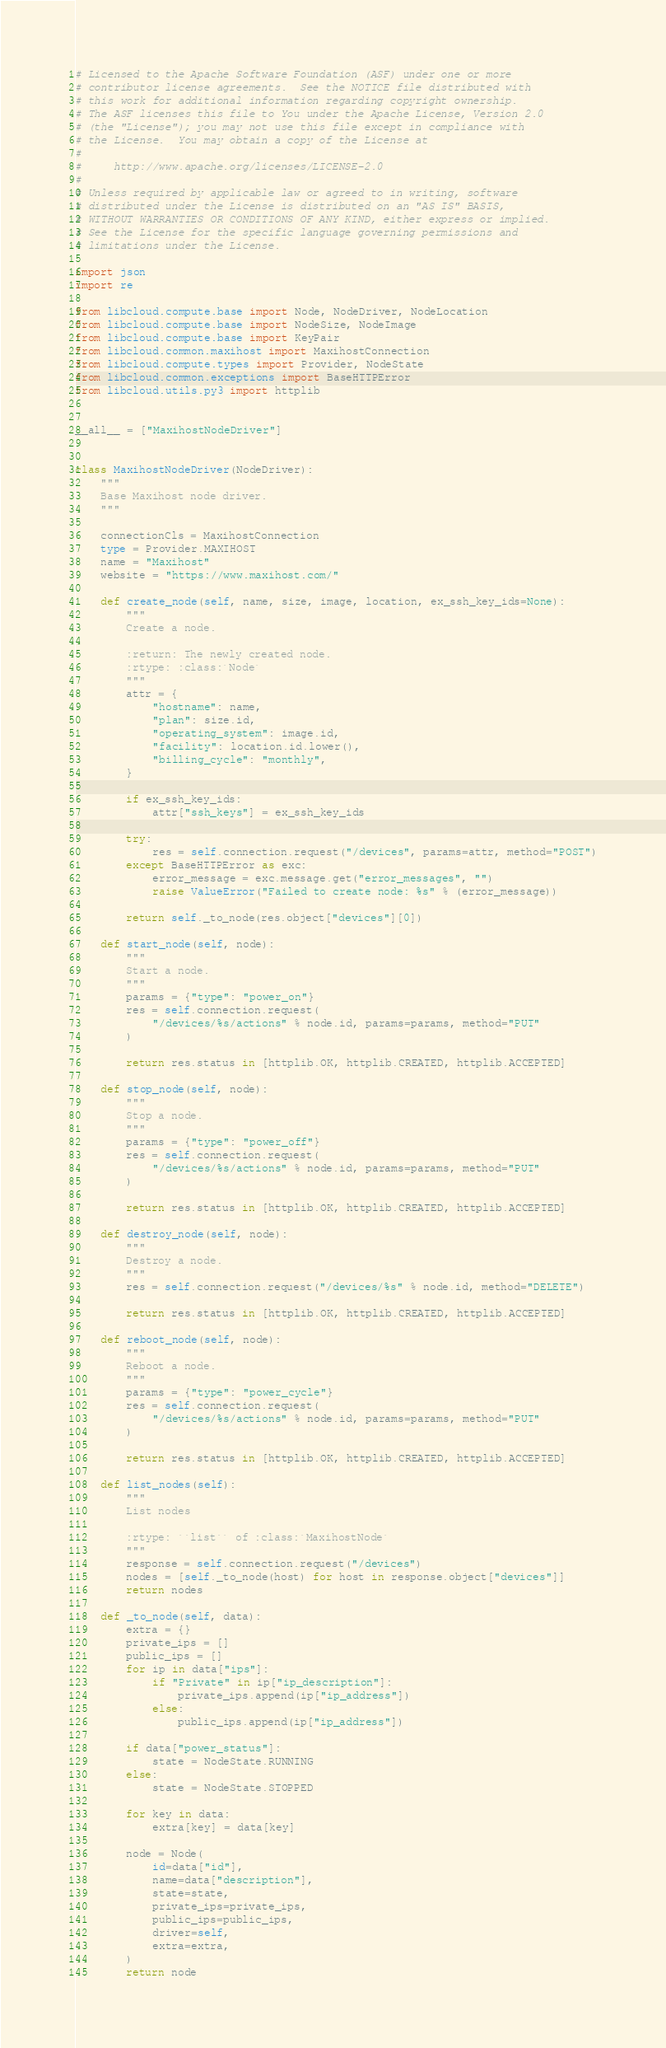Convert code to text. <code><loc_0><loc_0><loc_500><loc_500><_Python_># Licensed to the Apache Software Foundation (ASF) under one or more
# contributor license agreements.  See the NOTICE file distributed with
# this work for additional information regarding copyright ownership.
# The ASF licenses this file to You under the Apache License, Version 2.0
# (the "License"); you may not use this file except in compliance with
# the License.  You may obtain a copy of the License at
#
#     http://www.apache.org/licenses/LICENSE-2.0
#
# Unless required by applicable law or agreed to in writing, software
# distributed under the License is distributed on an "AS IS" BASIS,
# WITHOUT WARRANTIES OR CONDITIONS OF ANY KIND, either express or implied.
# See the License for the specific language governing permissions and
# limitations under the License.

import json
import re

from libcloud.compute.base import Node, NodeDriver, NodeLocation
from libcloud.compute.base import NodeSize, NodeImage
from libcloud.compute.base import KeyPair
from libcloud.common.maxihost import MaxihostConnection
from libcloud.compute.types import Provider, NodeState
from libcloud.common.exceptions import BaseHTTPError
from libcloud.utils.py3 import httplib


__all__ = ["MaxihostNodeDriver"]


class MaxihostNodeDriver(NodeDriver):
    """
    Base Maxihost node driver.
    """

    connectionCls = MaxihostConnection
    type = Provider.MAXIHOST
    name = "Maxihost"
    website = "https://www.maxihost.com/"

    def create_node(self, name, size, image, location, ex_ssh_key_ids=None):
        """
        Create a node.

        :return: The newly created node.
        :rtype: :class:`Node`
        """
        attr = {
            "hostname": name,
            "plan": size.id,
            "operating_system": image.id,
            "facility": location.id.lower(),
            "billing_cycle": "monthly",
        }

        if ex_ssh_key_ids:
            attr["ssh_keys"] = ex_ssh_key_ids

        try:
            res = self.connection.request("/devices", params=attr, method="POST")
        except BaseHTTPError as exc:
            error_message = exc.message.get("error_messages", "")
            raise ValueError("Failed to create node: %s" % (error_message))

        return self._to_node(res.object["devices"][0])

    def start_node(self, node):
        """
        Start a node.
        """
        params = {"type": "power_on"}
        res = self.connection.request(
            "/devices/%s/actions" % node.id, params=params, method="PUT"
        )

        return res.status in [httplib.OK, httplib.CREATED, httplib.ACCEPTED]

    def stop_node(self, node):
        """
        Stop a node.
        """
        params = {"type": "power_off"}
        res = self.connection.request(
            "/devices/%s/actions" % node.id, params=params, method="PUT"
        )

        return res.status in [httplib.OK, httplib.CREATED, httplib.ACCEPTED]

    def destroy_node(self, node):
        """
        Destroy a node.
        """
        res = self.connection.request("/devices/%s" % node.id, method="DELETE")

        return res.status in [httplib.OK, httplib.CREATED, httplib.ACCEPTED]

    def reboot_node(self, node):
        """
        Reboot a node.
        """
        params = {"type": "power_cycle"}
        res = self.connection.request(
            "/devices/%s/actions" % node.id, params=params, method="PUT"
        )

        return res.status in [httplib.OK, httplib.CREATED, httplib.ACCEPTED]

    def list_nodes(self):
        """
        List nodes

        :rtype: ``list`` of :class:`MaxihostNode`
        """
        response = self.connection.request("/devices")
        nodes = [self._to_node(host) for host in response.object["devices"]]
        return nodes

    def _to_node(self, data):
        extra = {}
        private_ips = []
        public_ips = []
        for ip in data["ips"]:
            if "Private" in ip["ip_description"]:
                private_ips.append(ip["ip_address"])
            else:
                public_ips.append(ip["ip_address"])

        if data["power_status"]:
            state = NodeState.RUNNING
        else:
            state = NodeState.STOPPED

        for key in data:
            extra[key] = data[key]

        node = Node(
            id=data["id"],
            name=data["description"],
            state=state,
            private_ips=private_ips,
            public_ips=public_ips,
            driver=self,
            extra=extra,
        )
        return node
</code> 